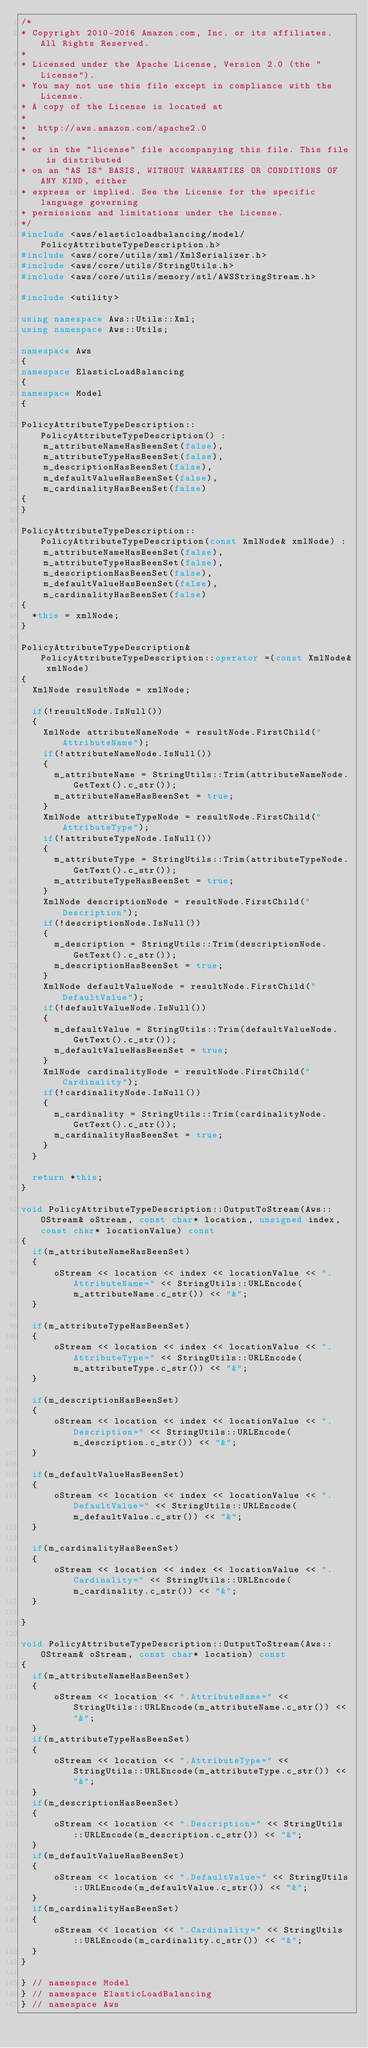Convert code to text. <code><loc_0><loc_0><loc_500><loc_500><_C++_>/*
* Copyright 2010-2016 Amazon.com, Inc. or its affiliates. All Rights Reserved.
*
* Licensed under the Apache License, Version 2.0 (the "License").
* You may not use this file except in compliance with the License.
* A copy of the License is located at
*
*  http://aws.amazon.com/apache2.0
*
* or in the "license" file accompanying this file. This file is distributed
* on an "AS IS" BASIS, WITHOUT WARRANTIES OR CONDITIONS OF ANY KIND, either
* express or implied. See the License for the specific language governing
* permissions and limitations under the License.
*/
#include <aws/elasticloadbalancing/model/PolicyAttributeTypeDescription.h>
#include <aws/core/utils/xml/XmlSerializer.h>
#include <aws/core/utils/StringUtils.h>
#include <aws/core/utils/memory/stl/AWSStringStream.h>

#include <utility>

using namespace Aws::Utils::Xml;
using namespace Aws::Utils;

namespace Aws
{
namespace ElasticLoadBalancing
{
namespace Model
{

PolicyAttributeTypeDescription::PolicyAttributeTypeDescription() : 
    m_attributeNameHasBeenSet(false),
    m_attributeTypeHasBeenSet(false),
    m_descriptionHasBeenSet(false),
    m_defaultValueHasBeenSet(false),
    m_cardinalityHasBeenSet(false)
{
}

PolicyAttributeTypeDescription::PolicyAttributeTypeDescription(const XmlNode& xmlNode) : 
    m_attributeNameHasBeenSet(false),
    m_attributeTypeHasBeenSet(false),
    m_descriptionHasBeenSet(false),
    m_defaultValueHasBeenSet(false),
    m_cardinalityHasBeenSet(false)
{
  *this = xmlNode;
}

PolicyAttributeTypeDescription& PolicyAttributeTypeDescription::operator =(const XmlNode& xmlNode)
{
  XmlNode resultNode = xmlNode;

  if(!resultNode.IsNull())
  {
    XmlNode attributeNameNode = resultNode.FirstChild("AttributeName");
    if(!attributeNameNode.IsNull())
    {
      m_attributeName = StringUtils::Trim(attributeNameNode.GetText().c_str());
      m_attributeNameHasBeenSet = true;
    }
    XmlNode attributeTypeNode = resultNode.FirstChild("AttributeType");
    if(!attributeTypeNode.IsNull())
    {
      m_attributeType = StringUtils::Trim(attributeTypeNode.GetText().c_str());
      m_attributeTypeHasBeenSet = true;
    }
    XmlNode descriptionNode = resultNode.FirstChild("Description");
    if(!descriptionNode.IsNull())
    {
      m_description = StringUtils::Trim(descriptionNode.GetText().c_str());
      m_descriptionHasBeenSet = true;
    }
    XmlNode defaultValueNode = resultNode.FirstChild("DefaultValue");
    if(!defaultValueNode.IsNull())
    {
      m_defaultValue = StringUtils::Trim(defaultValueNode.GetText().c_str());
      m_defaultValueHasBeenSet = true;
    }
    XmlNode cardinalityNode = resultNode.FirstChild("Cardinality");
    if(!cardinalityNode.IsNull())
    {
      m_cardinality = StringUtils::Trim(cardinalityNode.GetText().c_str());
      m_cardinalityHasBeenSet = true;
    }
  }

  return *this;
}

void PolicyAttributeTypeDescription::OutputToStream(Aws::OStream& oStream, const char* location, unsigned index, const char* locationValue) const
{
  if(m_attributeNameHasBeenSet)
  {
      oStream << location << index << locationValue << ".AttributeName=" << StringUtils::URLEncode(m_attributeName.c_str()) << "&";
  }

  if(m_attributeTypeHasBeenSet)
  {
      oStream << location << index << locationValue << ".AttributeType=" << StringUtils::URLEncode(m_attributeType.c_str()) << "&";
  }

  if(m_descriptionHasBeenSet)
  {
      oStream << location << index << locationValue << ".Description=" << StringUtils::URLEncode(m_description.c_str()) << "&";
  }

  if(m_defaultValueHasBeenSet)
  {
      oStream << location << index << locationValue << ".DefaultValue=" << StringUtils::URLEncode(m_defaultValue.c_str()) << "&";
  }

  if(m_cardinalityHasBeenSet)
  {
      oStream << location << index << locationValue << ".Cardinality=" << StringUtils::URLEncode(m_cardinality.c_str()) << "&";
  }

}

void PolicyAttributeTypeDescription::OutputToStream(Aws::OStream& oStream, const char* location) const
{
  if(m_attributeNameHasBeenSet)
  {
      oStream << location << ".AttributeName=" << StringUtils::URLEncode(m_attributeName.c_str()) << "&";
  }
  if(m_attributeTypeHasBeenSet)
  {
      oStream << location << ".AttributeType=" << StringUtils::URLEncode(m_attributeType.c_str()) << "&";
  }
  if(m_descriptionHasBeenSet)
  {
      oStream << location << ".Description=" << StringUtils::URLEncode(m_description.c_str()) << "&";
  }
  if(m_defaultValueHasBeenSet)
  {
      oStream << location << ".DefaultValue=" << StringUtils::URLEncode(m_defaultValue.c_str()) << "&";
  }
  if(m_cardinalityHasBeenSet)
  {
      oStream << location << ".Cardinality=" << StringUtils::URLEncode(m_cardinality.c_str()) << "&";
  }
}

} // namespace Model
} // namespace ElasticLoadBalancing
} // namespace Aws
</code> 